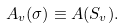Convert formula to latex. <formula><loc_0><loc_0><loc_500><loc_500>A _ { v } ( \sigma ) \equiv A ( S _ { v } ) .</formula> 